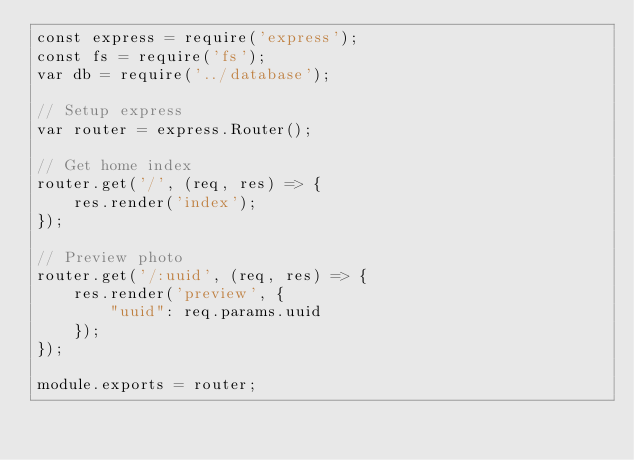<code> <loc_0><loc_0><loc_500><loc_500><_JavaScript_>const express = require('express');
const fs = require('fs');
var db = require('../database');

// Setup express
var router = express.Router();

// Get home index
router.get('/', (req, res) => {
    res.render('index');
});

// Preview photo
router.get('/:uuid', (req, res) => {
    res.render('preview', {
        "uuid": req.params.uuid
    });
});

module.exports = router;</code> 